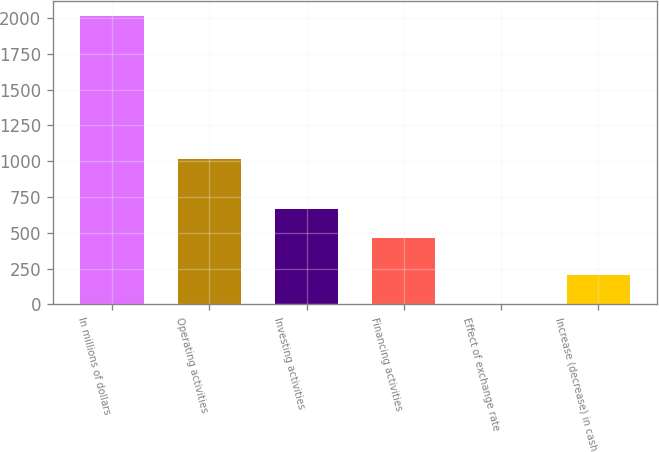Convert chart. <chart><loc_0><loc_0><loc_500><loc_500><bar_chart><fcel>In millions of dollars<fcel>Operating activities<fcel>Investing activities<fcel>Financing activities<fcel>Effect of exchange rate<fcel>Increase (decrease) in cash<nl><fcel>2016<fcel>1013.4<fcel>665.69<fcel>464.4<fcel>3.1<fcel>204.39<nl></chart> 